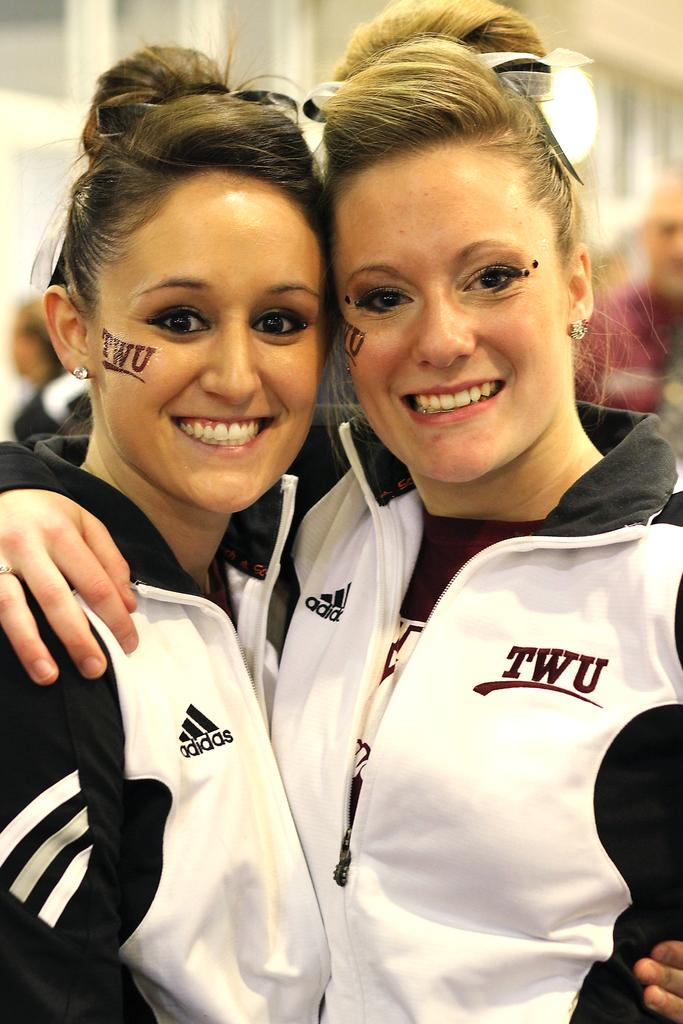Provide a one-sentence caption for the provided image. Two pony-tailed TWU students smile at the camera. 